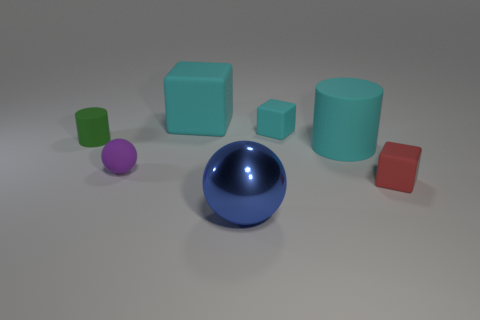Add 2 purple shiny blocks. How many objects exist? 9 Subtract all blocks. How many objects are left? 4 Subtract 0 yellow cylinders. How many objects are left? 7 Subtract all big shiny blocks. Subtract all green rubber cylinders. How many objects are left? 6 Add 6 large blue balls. How many large blue balls are left? 7 Add 1 brown matte spheres. How many brown matte spheres exist? 1 